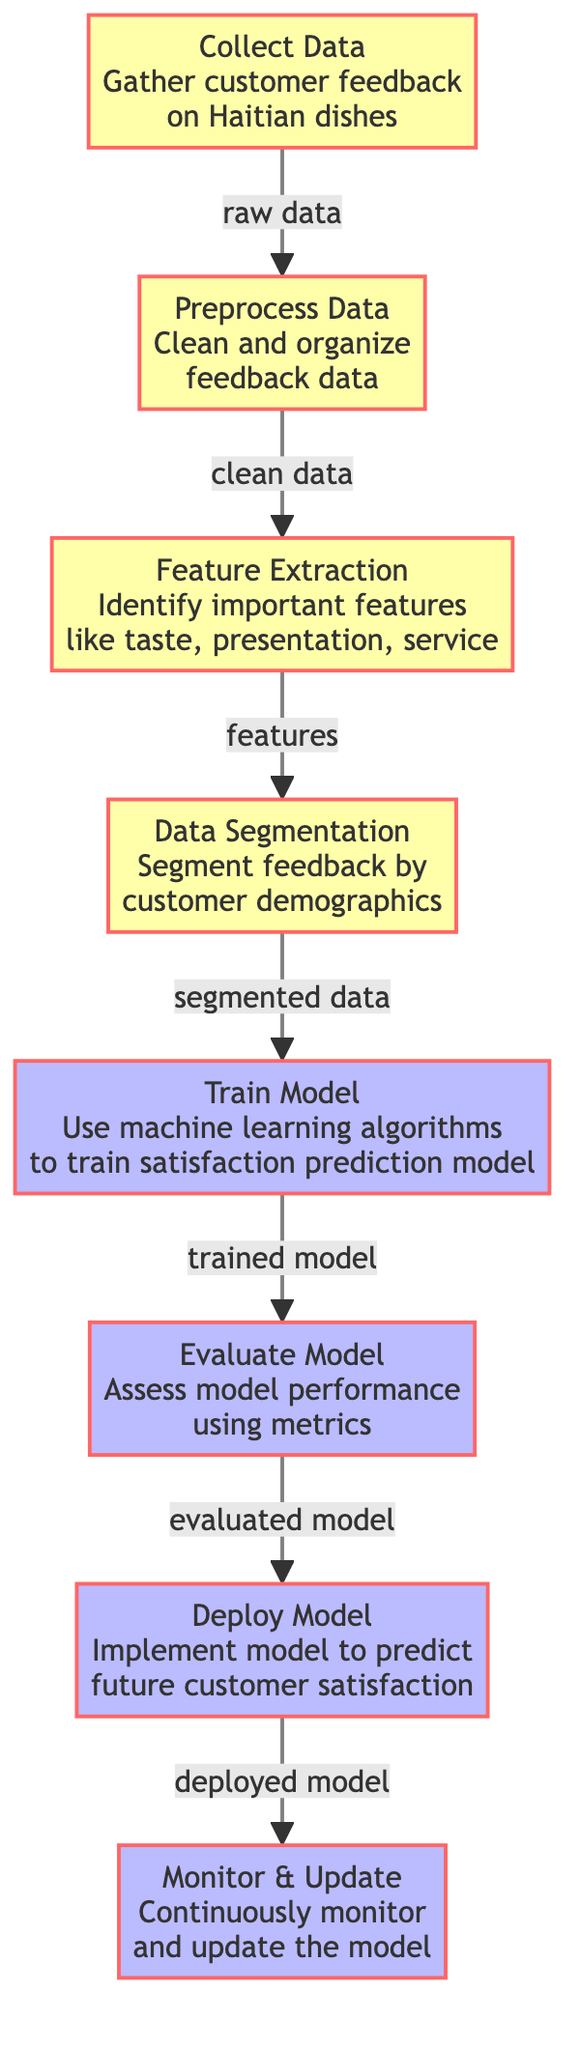What is the first step in the diagram? The diagram starts with the node labeled "Collect Data," indicating that the first task is gathering customer feedback on Haitian dishes.
Answer: Collect Data How many processes are in the diagram? The diagram contains five distinct processes: Train Model, Evaluate Model, Deploy Model, and Monitor & Update, which indicates the main actions taken after data preprocessing and feature extraction.
Answer: Five What type of data is output from the "Preprocess Data" step? The output after the "Preprocess Data" step is labeled as "clean data," indicating it has been organized and cleaned for further analysis.
Answer: Clean Data What happens after "Feature Extraction"? Following the "Feature Extraction" node, the data is passed to the "Data Segmentation" node, which indicates that the identified features are then segmented by customer demographics for deeper analysis.
Answer: Data Segmentation How is the model performance assessed? The performance of the model is assessed through the "Evaluate Model" step, indicating that this stage uses specific metrics to determine how well the model performs.
Answer: Using metrics What is the final process in the diagram? The last process in the sequence is "Monitor & Update," showcasing the ongoing effort to ensure the model remains accurate and relevant after deployment.
Answer: Monitor & Update Which node follows "Train Model"? The node that comes after "Train Model" is "Evaluate Model," indicating a logical progression in the workflow where the trained model is then assessed for its accuracy and effectiveness.
Answer: Evaluate Model What action is taken after deploying the model? After deploying the model, the action taken is "Monitor & Update," suggesting a continuous cycle of oversight to maintain the model's performance.
Answer: Monitor & Update 